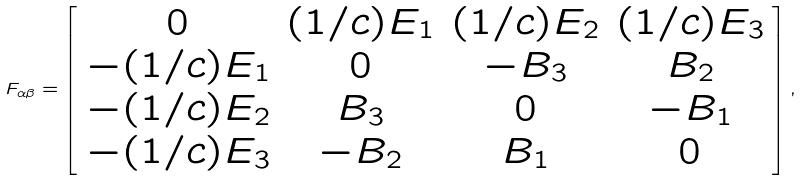Convert formula to latex. <formula><loc_0><loc_0><loc_500><loc_500>F _ { \alpha \beta } = \left [ \begin{array} { c c c c } 0 & ( 1 / c ) E _ { 1 } & ( 1 / c ) E _ { 2 } & ( 1 / c ) E _ { 3 } \\ - ( 1 / c ) E _ { 1 } & 0 & - B _ { 3 } & B _ { 2 } \\ - ( 1 / c ) E _ { 2 } & B _ { 3 } & 0 & - B _ { 1 } \\ - ( 1 / c ) E _ { 3 } & - B _ { 2 } & B _ { 1 } & 0 \end{array} \right ] ,</formula> 